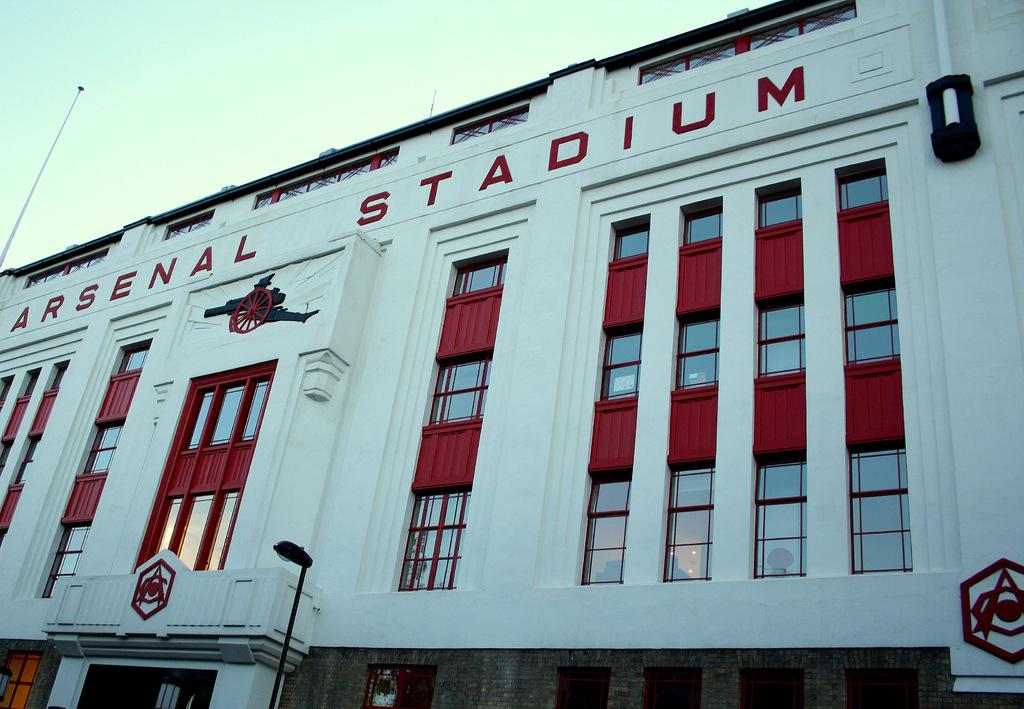What structures are present in the image? There are poles and a building with windows in the image. Can you describe the building in the image? The building has windows. What is visible in the background of the image? The sky is visible in the background of the image. What type of sack can be seen on the front of the building in the image? There is no sack present on the front of the building in the image. What type of cap is worn by the pole in the image? There are no caps worn by the poles in the image, as poles do not have the ability to wear caps. 